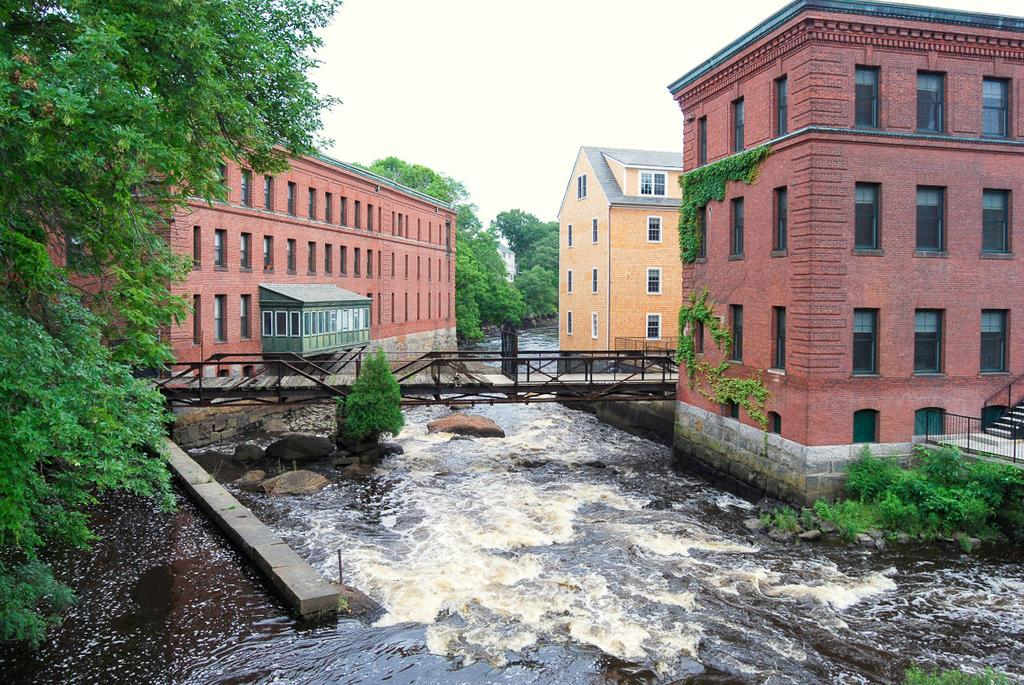What is the main feature in the middle of the image? There is a river flowing in the middle of the image. What structure is present in the image? There is a bridge in the image. What type of buildings can be seen on either side of the image? There are houses on either side of the image. What type of vegetation is on the left side of the image? There are trees on the left side of the image. What is visible at the top of the image? The sky is visible at the top of the image. How many letters are being folded on the bridge in the image? There are no letters or folding activity present in the image. What type of work is being done by the trees on the left side of the image? The trees are not performing any work in the image; they are simply vegetation. 